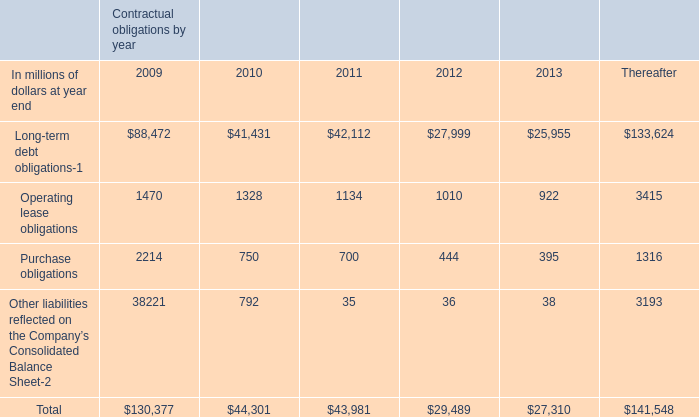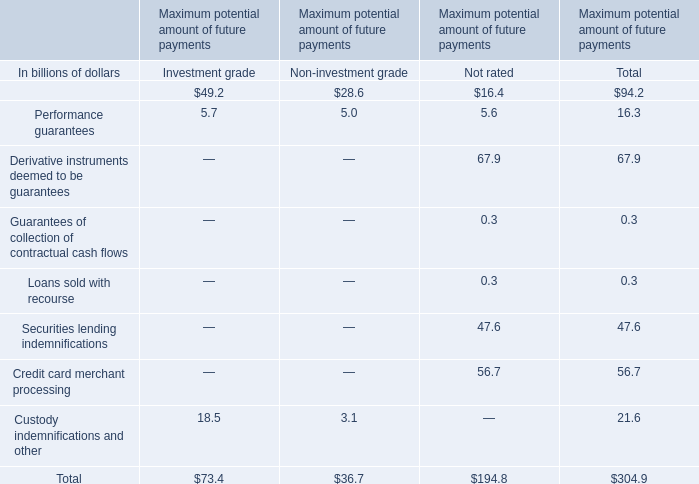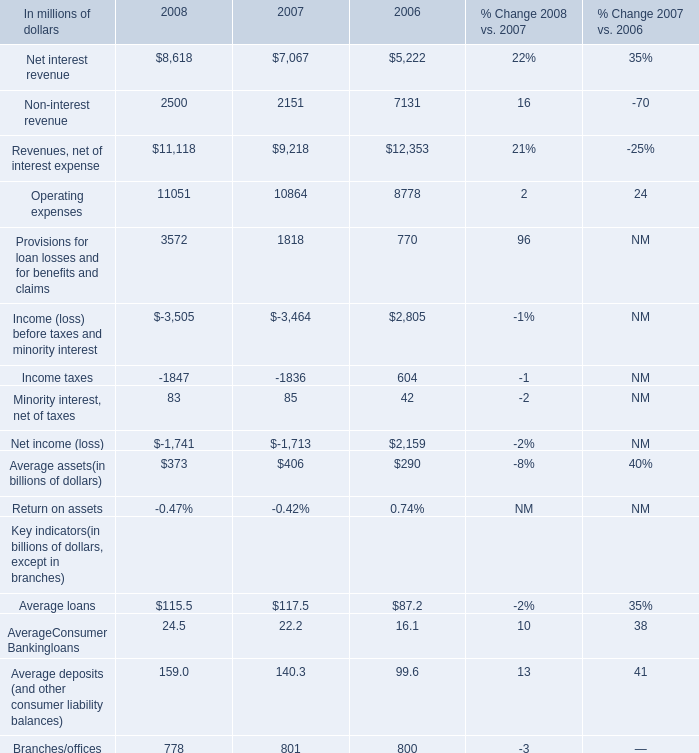What was the total amount of the Performance guarantees in the sections where Financial standby letters of credit is greater than 40 billion? (in billion) 
Computations: ((5.7 + 5.0) + 5.6)
Answer: 16.3. 